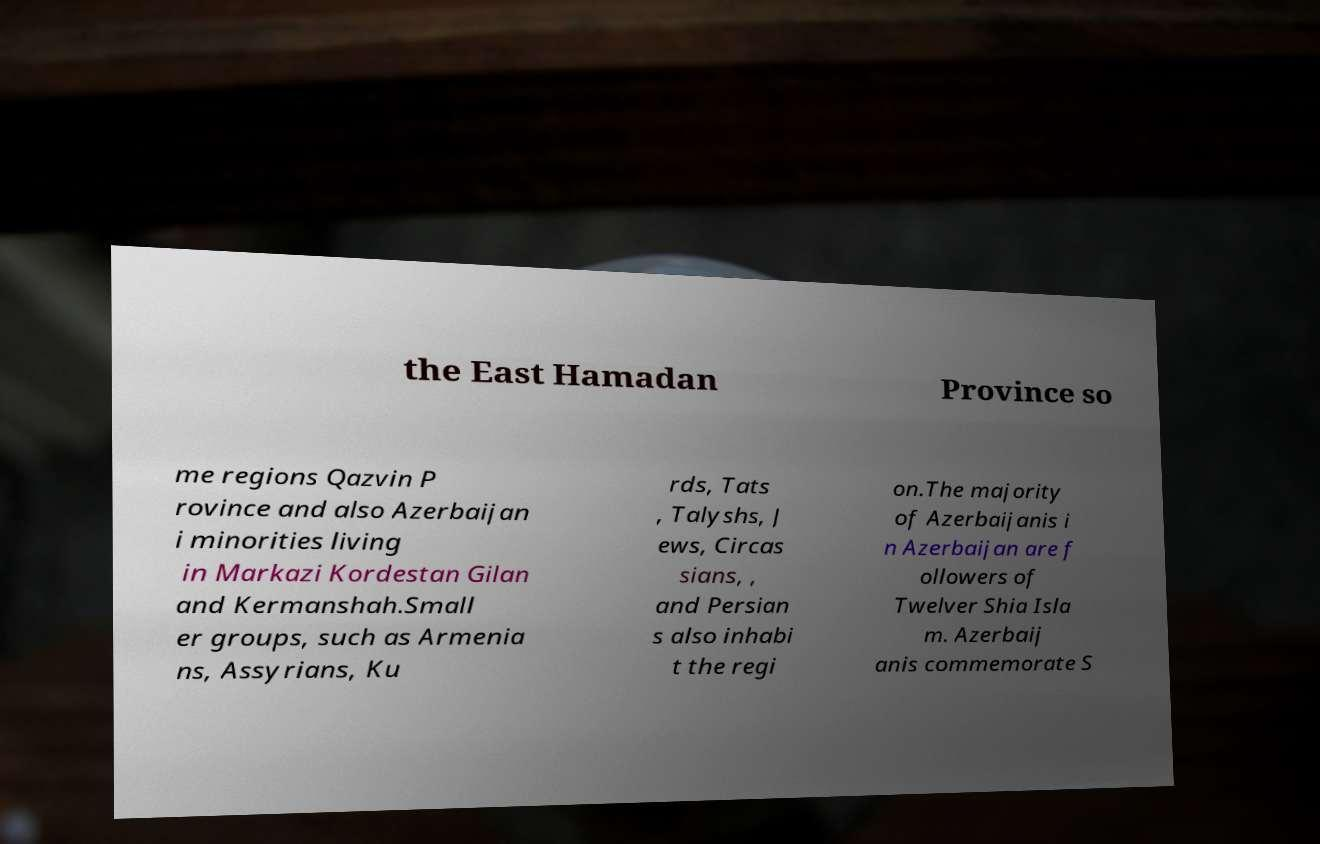Please read and relay the text visible in this image. What does it say? the East Hamadan Province so me regions Qazvin P rovince and also Azerbaijan i minorities living in Markazi Kordestan Gilan and Kermanshah.Small er groups, such as Armenia ns, Assyrians, Ku rds, Tats , Talyshs, J ews, Circas sians, , and Persian s also inhabi t the regi on.The majority of Azerbaijanis i n Azerbaijan are f ollowers of Twelver Shia Isla m. Azerbaij anis commemorate S 